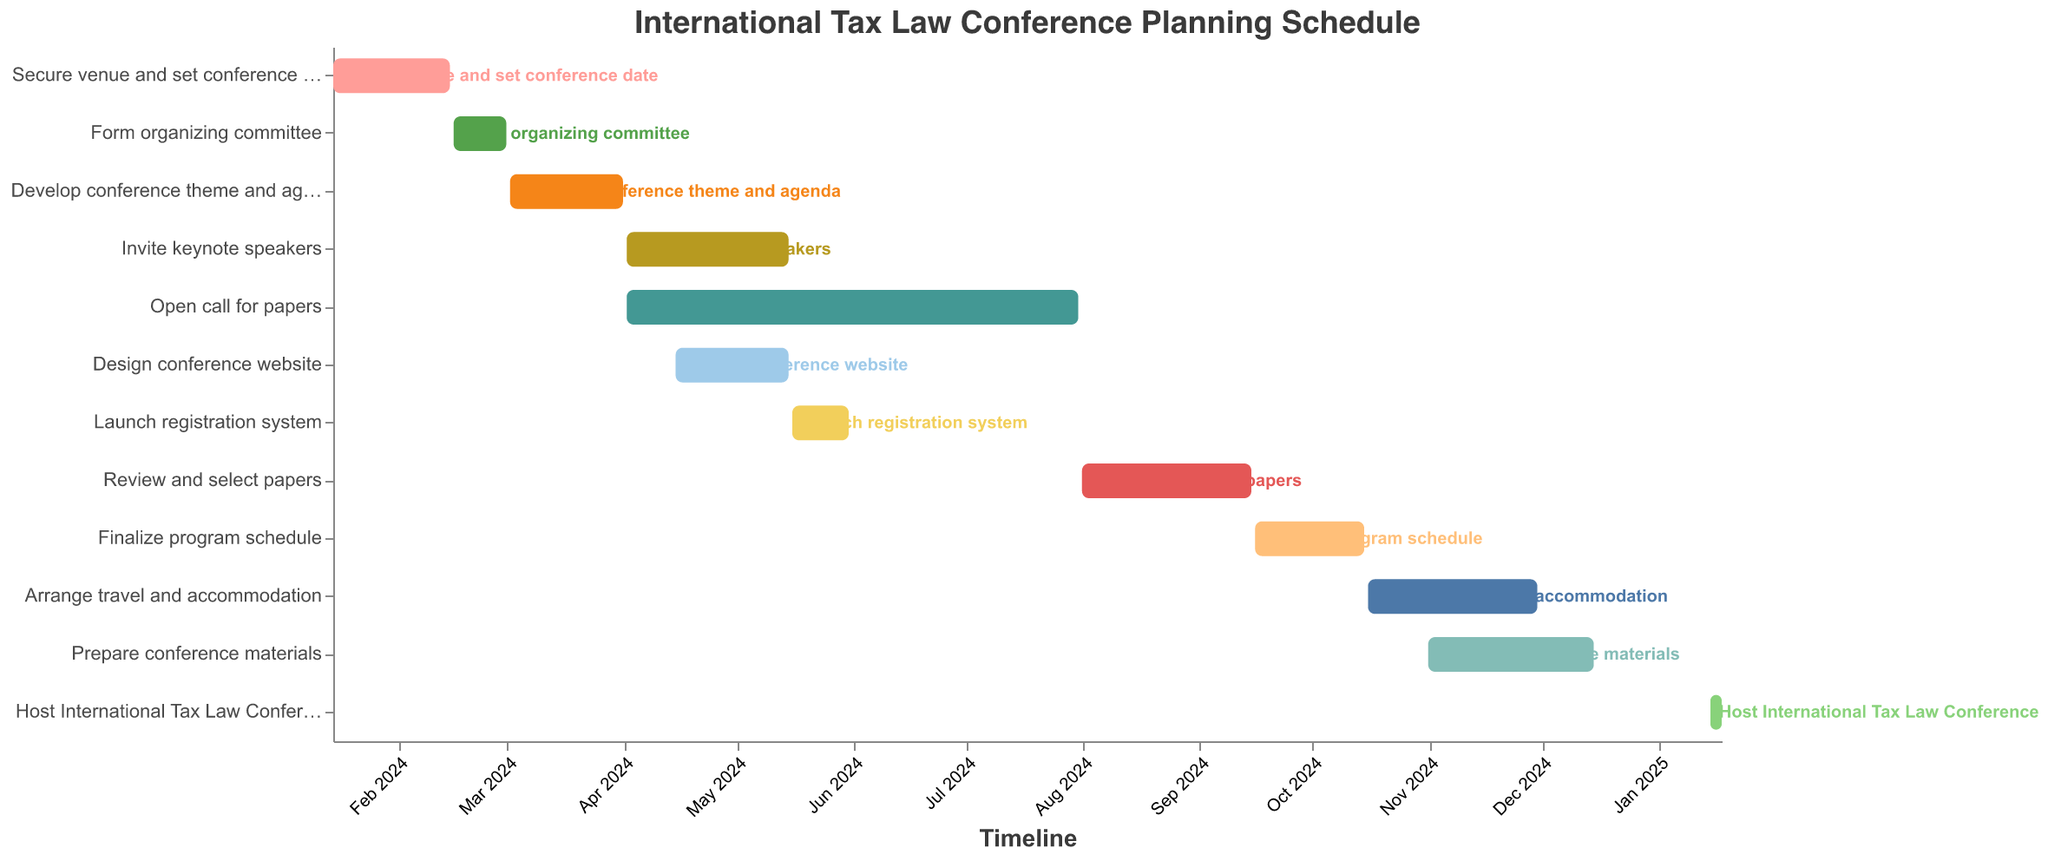When does the "Secure venue and set conference date" task start and end? The "Secure venue and set conference date" task starts on January 15, 2024, and ends on February 15, 2024. This can be seen from the task bar's start and end points on the timeline.
Answer: January 15, 2024 to February 15, 2024 Which task has the longest duration? Among the tasks listed in the timeline, the "Open call for papers" task extends from April 2, 2024, to July 31, 2024, totaling 120 days, making it the task with the longest duration.
Answer: Open call for papers What is the total duration of "Review and select papers" and "Finalize program schedule" combined? The duration of the "Review and select papers" task is 45 days and the "Finalize program schedule" task lasts 29 days. Adding these durations together gives us 45 + 29 = 74 days.
Answer: 74 days Which task starts immediately after the "Form organizing committee" task ends? The "Develop conference theme and agenda" task starts immediately after the "Form organizing committee" task ends. The former ends on March 1, 2024, and the latter starts on March 2, 2024.
Answer: Develop conference theme and agenda During which months is the "Invite keynote speakers" task executed? The "Invite keynote speakers" task starts on April 2, 2024, and ends on May 15, 2024. This time period includes the months of April and May.
Answer: April and May Which task overlaps with the "Design conference website" task in terms of timeline? The "Invite keynote speakers" and "Open call for papers" tasks overlap with the "Design conference website" task. All three tasks are being executed concurrently in April and May 2024.
Answer: Invite keynote speakers and Open call for papers How many days are between the start of "Prepare conference materials" and the end of "Arrange travel and accommodation"? The "Prepare conference materials" starts on November 1, 2024, and "Arrange travel and accommodation" ends on November 30, 2024. From November 1 to November 30 is 30 days.
Answer: 30 days What is the final task in the schedule, and when does it occur? The final task in the schedule is "Host International Tax Law Conference," which occurs from January 15, 2025, to January 18, 2025. This can be determined from the timeline's ending points.
Answer: Host International Tax Law Conference, January 15-18, 2025 At what point does the "Launch registration system" task occur in the timeline? The "Launch registration system" task occurs between May 16, 2024, and May 31, 2024. We can see this from the start and end points of the task bar on the timeline.
Answer: May 16, 2024, to May 31, 2024 Which task has the shortest duration, and how many days is it? The task with the shortest duration is "Host International Tax Law Conference," lasting only 3 days from January 15, 2025, to January 18, 2025. This is evident from the length of the task bar on the timeline.
Answer: Host International Tax Law Conference, 3 days 